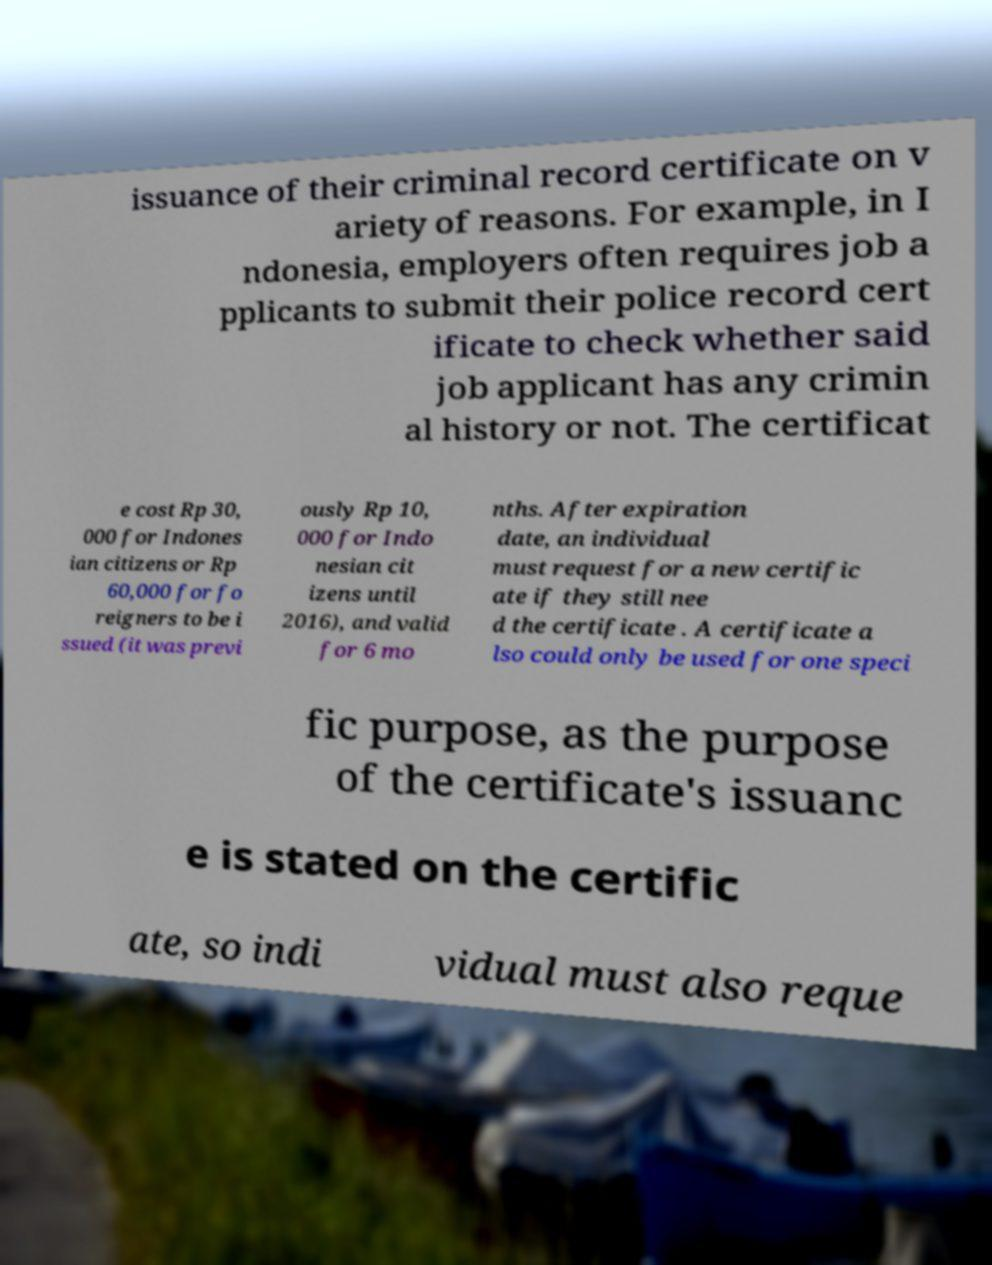Could you assist in decoding the text presented in this image and type it out clearly? issuance of their criminal record certificate on v ariety of reasons. For example, in I ndonesia, employers often requires job a pplicants to submit their police record cert ificate to check whether said job applicant has any crimin al history or not. The certificat e cost Rp 30, 000 for Indones ian citizens or Rp 60,000 for fo reigners to be i ssued (it was previ ously Rp 10, 000 for Indo nesian cit izens until 2016), and valid for 6 mo nths. After expiration date, an individual must request for a new certific ate if they still nee d the certificate . A certificate a lso could only be used for one speci fic purpose, as the purpose of the certificate's issuanc e is stated on the certific ate, so indi vidual must also reque 